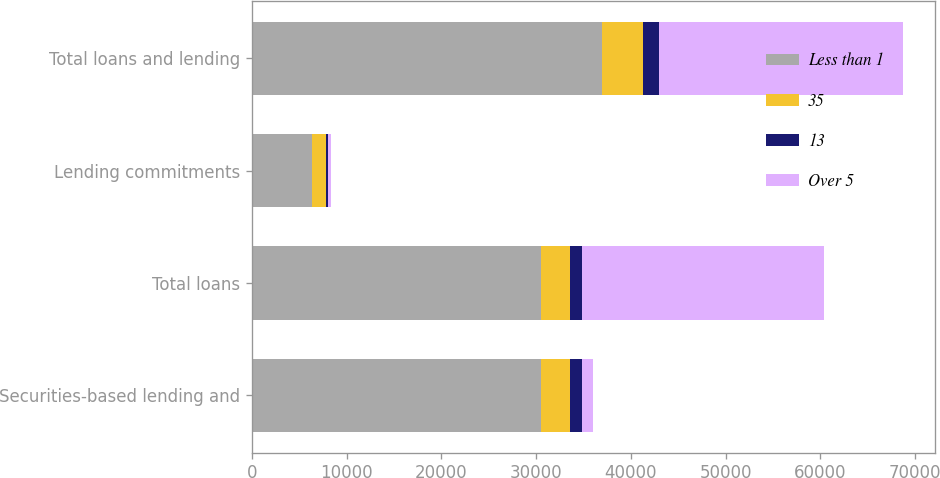<chart> <loc_0><loc_0><loc_500><loc_500><stacked_bar_chart><ecel><fcel>Securities-based lending and<fcel>Total loans<fcel>Lending commitments<fcel>Total loans and lending<nl><fcel>Less than 1<fcel>30547<fcel>30547<fcel>6372<fcel>36919<nl><fcel>35<fcel>2983<fcel>2983<fcel>1413<fcel>4396<nl><fcel>13<fcel>1304<fcel>1349<fcel>268<fcel>1617<nl><fcel>Over 5<fcel>1179<fcel>25548<fcel>246<fcel>25794<nl></chart> 